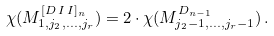Convert formula to latex. <formula><loc_0><loc_0><loc_500><loc_500>\chi ( M ^ { [ D \, I \, I ] _ { n } } _ { 1 , j _ { 2 } , \hdots , j _ { r } } ) = 2 \cdot \chi ( M ^ { D _ { n - 1 } } _ { j _ { 2 } - 1 , \hdots , j _ { r } - 1 } ) \, .</formula> 